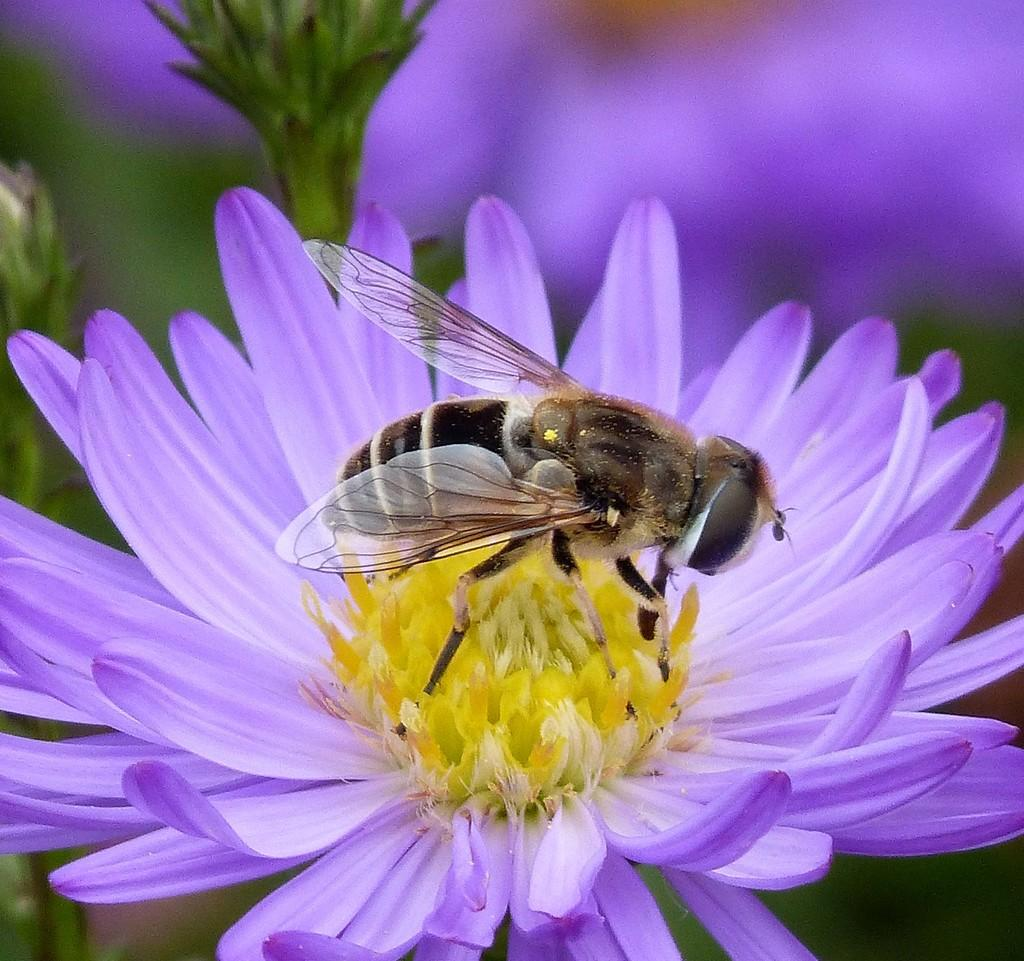What type of insect is present in the image? There is a bee in the image. Where is the bee located in the image? The bee is present on a flower. What type of food is being served in the lunchroom in the image? There is no lunchroom present in the image; it only features a bee on a flower. 